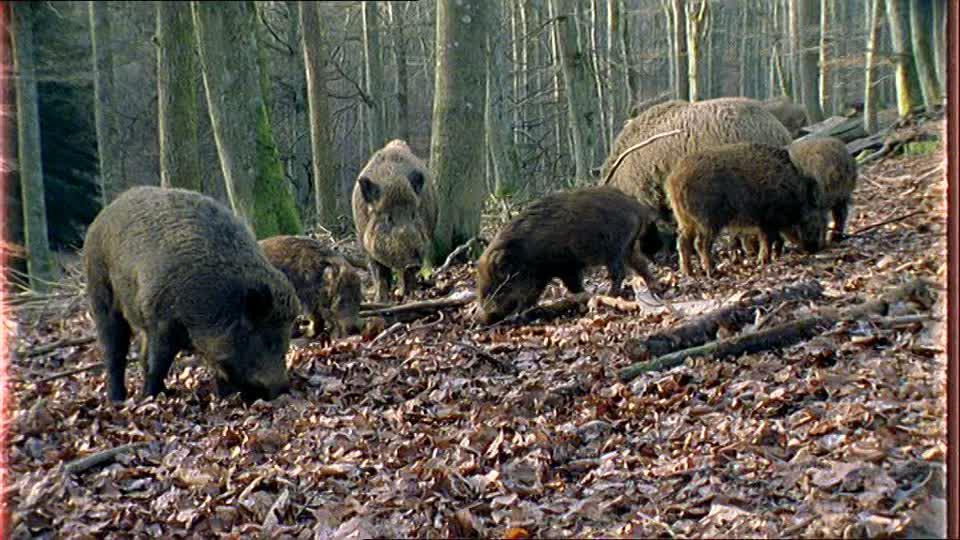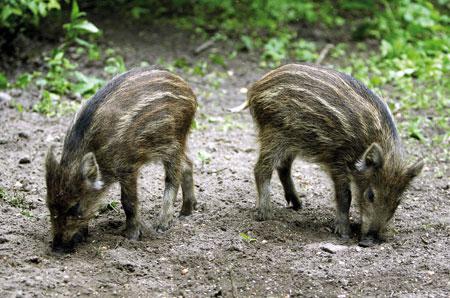The first image is the image on the left, the second image is the image on the right. Considering the images on both sides, is "An image contains exactly two pigs, which are striped juveniles." valid? Answer yes or no. Yes. 